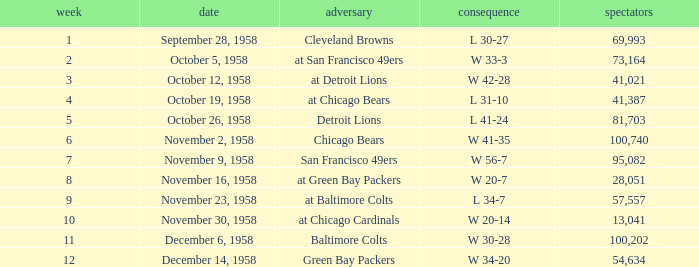On november 9, 1958, what was the largest attendance recorded? 95082.0. 